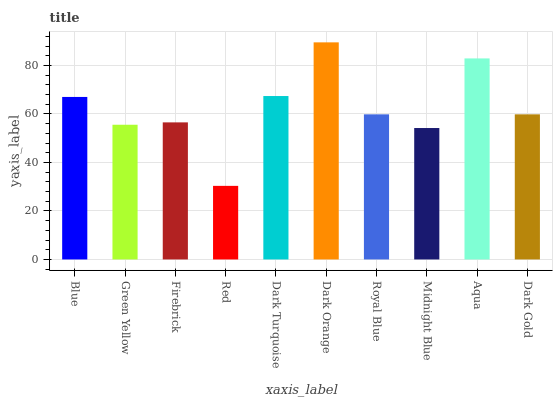Is Red the minimum?
Answer yes or no. Yes. Is Dark Orange the maximum?
Answer yes or no. Yes. Is Green Yellow the minimum?
Answer yes or no. No. Is Green Yellow the maximum?
Answer yes or no. No. Is Blue greater than Green Yellow?
Answer yes or no. Yes. Is Green Yellow less than Blue?
Answer yes or no. Yes. Is Green Yellow greater than Blue?
Answer yes or no. No. Is Blue less than Green Yellow?
Answer yes or no. No. Is Royal Blue the high median?
Answer yes or no. Yes. Is Dark Gold the low median?
Answer yes or no. Yes. Is Aqua the high median?
Answer yes or no. No. Is Blue the low median?
Answer yes or no. No. 